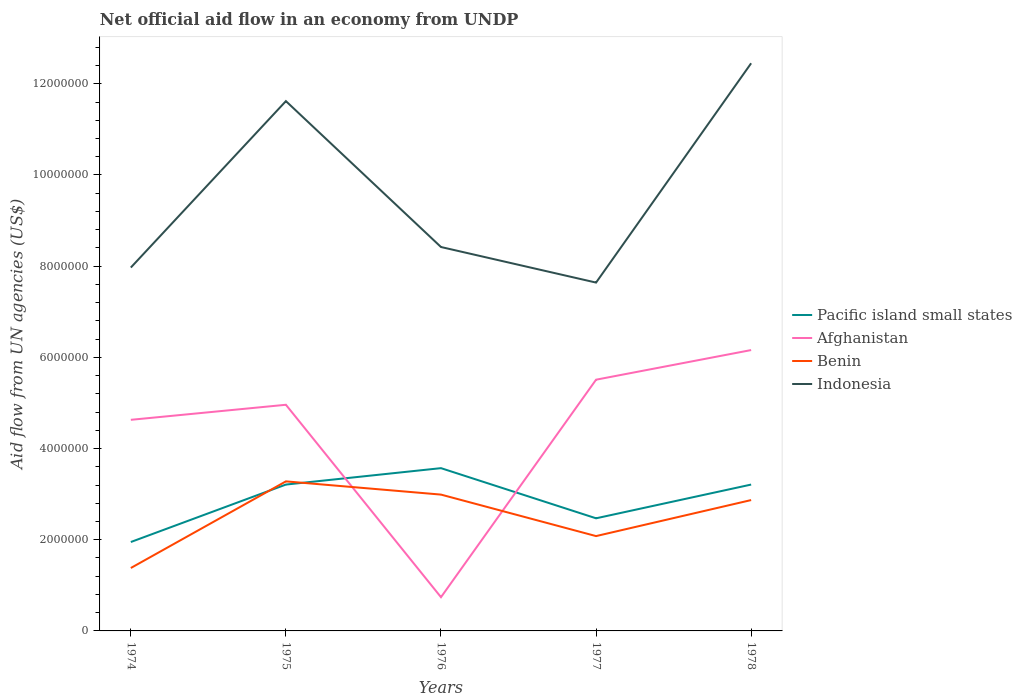How many different coloured lines are there?
Provide a succinct answer. 4. Is the number of lines equal to the number of legend labels?
Make the answer very short. Yes. Across all years, what is the maximum net official aid flow in Benin?
Make the answer very short. 1.38e+06. In which year was the net official aid flow in Benin maximum?
Offer a very short reply. 1974. What is the total net official aid flow in Indonesia in the graph?
Ensure brevity in your answer.  -4.48e+06. What is the difference between the highest and the second highest net official aid flow in Benin?
Offer a very short reply. 1.90e+06. What is the difference between the highest and the lowest net official aid flow in Indonesia?
Your answer should be very brief. 2. Are the values on the major ticks of Y-axis written in scientific E-notation?
Ensure brevity in your answer.  No. Does the graph contain any zero values?
Offer a very short reply. No. Does the graph contain grids?
Your response must be concise. No. What is the title of the graph?
Offer a very short reply. Net official aid flow in an economy from UNDP. Does "Lithuania" appear as one of the legend labels in the graph?
Provide a succinct answer. No. What is the label or title of the Y-axis?
Provide a succinct answer. Aid flow from UN agencies (US$). What is the Aid flow from UN agencies (US$) in Pacific island small states in 1974?
Ensure brevity in your answer.  1.95e+06. What is the Aid flow from UN agencies (US$) of Afghanistan in 1974?
Offer a very short reply. 4.63e+06. What is the Aid flow from UN agencies (US$) of Benin in 1974?
Your answer should be very brief. 1.38e+06. What is the Aid flow from UN agencies (US$) in Indonesia in 1974?
Provide a short and direct response. 7.97e+06. What is the Aid flow from UN agencies (US$) in Pacific island small states in 1975?
Provide a short and direct response. 3.21e+06. What is the Aid flow from UN agencies (US$) of Afghanistan in 1975?
Keep it short and to the point. 4.96e+06. What is the Aid flow from UN agencies (US$) of Benin in 1975?
Your response must be concise. 3.28e+06. What is the Aid flow from UN agencies (US$) of Indonesia in 1975?
Your answer should be compact. 1.16e+07. What is the Aid flow from UN agencies (US$) in Pacific island small states in 1976?
Provide a succinct answer. 3.57e+06. What is the Aid flow from UN agencies (US$) of Afghanistan in 1976?
Give a very brief answer. 7.40e+05. What is the Aid flow from UN agencies (US$) in Benin in 1976?
Your response must be concise. 2.99e+06. What is the Aid flow from UN agencies (US$) of Indonesia in 1976?
Your response must be concise. 8.42e+06. What is the Aid flow from UN agencies (US$) in Pacific island small states in 1977?
Provide a succinct answer. 2.47e+06. What is the Aid flow from UN agencies (US$) in Afghanistan in 1977?
Keep it short and to the point. 5.51e+06. What is the Aid flow from UN agencies (US$) in Benin in 1977?
Keep it short and to the point. 2.08e+06. What is the Aid flow from UN agencies (US$) in Indonesia in 1977?
Your answer should be compact. 7.64e+06. What is the Aid flow from UN agencies (US$) of Pacific island small states in 1978?
Provide a succinct answer. 3.21e+06. What is the Aid flow from UN agencies (US$) in Afghanistan in 1978?
Ensure brevity in your answer.  6.16e+06. What is the Aid flow from UN agencies (US$) of Benin in 1978?
Ensure brevity in your answer.  2.87e+06. What is the Aid flow from UN agencies (US$) in Indonesia in 1978?
Offer a terse response. 1.24e+07. Across all years, what is the maximum Aid flow from UN agencies (US$) of Pacific island small states?
Give a very brief answer. 3.57e+06. Across all years, what is the maximum Aid flow from UN agencies (US$) in Afghanistan?
Provide a short and direct response. 6.16e+06. Across all years, what is the maximum Aid flow from UN agencies (US$) in Benin?
Your response must be concise. 3.28e+06. Across all years, what is the maximum Aid flow from UN agencies (US$) in Indonesia?
Offer a terse response. 1.24e+07. Across all years, what is the minimum Aid flow from UN agencies (US$) in Pacific island small states?
Provide a short and direct response. 1.95e+06. Across all years, what is the minimum Aid flow from UN agencies (US$) of Afghanistan?
Your answer should be very brief. 7.40e+05. Across all years, what is the minimum Aid flow from UN agencies (US$) of Benin?
Offer a very short reply. 1.38e+06. Across all years, what is the minimum Aid flow from UN agencies (US$) in Indonesia?
Your answer should be very brief. 7.64e+06. What is the total Aid flow from UN agencies (US$) in Pacific island small states in the graph?
Give a very brief answer. 1.44e+07. What is the total Aid flow from UN agencies (US$) of Afghanistan in the graph?
Provide a succinct answer. 2.20e+07. What is the total Aid flow from UN agencies (US$) in Benin in the graph?
Your response must be concise. 1.26e+07. What is the total Aid flow from UN agencies (US$) in Indonesia in the graph?
Give a very brief answer. 4.81e+07. What is the difference between the Aid flow from UN agencies (US$) of Pacific island small states in 1974 and that in 1975?
Provide a short and direct response. -1.26e+06. What is the difference between the Aid flow from UN agencies (US$) of Afghanistan in 1974 and that in 1975?
Offer a very short reply. -3.30e+05. What is the difference between the Aid flow from UN agencies (US$) of Benin in 1974 and that in 1975?
Ensure brevity in your answer.  -1.90e+06. What is the difference between the Aid flow from UN agencies (US$) in Indonesia in 1974 and that in 1975?
Keep it short and to the point. -3.65e+06. What is the difference between the Aid flow from UN agencies (US$) of Pacific island small states in 1974 and that in 1976?
Make the answer very short. -1.62e+06. What is the difference between the Aid flow from UN agencies (US$) of Afghanistan in 1974 and that in 1976?
Ensure brevity in your answer.  3.89e+06. What is the difference between the Aid flow from UN agencies (US$) in Benin in 1974 and that in 1976?
Provide a succinct answer. -1.61e+06. What is the difference between the Aid flow from UN agencies (US$) in Indonesia in 1974 and that in 1976?
Your answer should be very brief. -4.50e+05. What is the difference between the Aid flow from UN agencies (US$) in Pacific island small states in 1974 and that in 1977?
Keep it short and to the point. -5.20e+05. What is the difference between the Aid flow from UN agencies (US$) of Afghanistan in 1974 and that in 1977?
Make the answer very short. -8.80e+05. What is the difference between the Aid flow from UN agencies (US$) of Benin in 1974 and that in 1977?
Provide a succinct answer. -7.00e+05. What is the difference between the Aid flow from UN agencies (US$) in Indonesia in 1974 and that in 1977?
Make the answer very short. 3.30e+05. What is the difference between the Aid flow from UN agencies (US$) of Pacific island small states in 1974 and that in 1978?
Your answer should be very brief. -1.26e+06. What is the difference between the Aid flow from UN agencies (US$) of Afghanistan in 1974 and that in 1978?
Provide a succinct answer. -1.53e+06. What is the difference between the Aid flow from UN agencies (US$) in Benin in 1974 and that in 1978?
Offer a terse response. -1.49e+06. What is the difference between the Aid flow from UN agencies (US$) in Indonesia in 1974 and that in 1978?
Your answer should be very brief. -4.48e+06. What is the difference between the Aid flow from UN agencies (US$) in Pacific island small states in 1975 and that in 1976?
Your response must be concise. -3.60e+05. What is the difference between the Aid flow from UN agencies (US$) in Afghanistan in 1975 and that in 1976?
Offer a terse response. 4.22e+06. What is the difference between the Aid flow from UN agencies (US$) in Benin in 1975 and that in 1976?
Ensure brevity in your answer.  2.90e+05. What is the difference between the Aid flow from UN agencies (US$) of Indonesia in 1975 and that in 1976?
Your answer should be compact. 3.20e+06. What is the difference between the Aid flow from UN agencies (US$) in Pacific island small states in 1975 and that in 1977?
Offer a terse response. 7.40e+05. What is the difference between the Aid flow from UN agencies (US$) in Afghanistan in 1975 and that in 1977?
Your response must be concise. -5.50e+05. What is the difference between the Aid flow from UN agencies (US$) of Benin in 1975 and that in 1977?
Your answer should be very brief. 1.20e+06. What is the difference between the Aid flow from UN agencies (US$) in Indonesia in 1975 and that in 1977?
Make the answer very short. 3.98e+06. What is the difference between the Aid flow from UN agencies (US$) of Pacific island small states in 1975 and that in 1978?
Give a very brief answer. 0. What is the difference between the Aid flow from UN agencies (US$) in Afghanistan in 1975 and that in 1978?
Ensure brevity in your answer.  -1.20e+06. What is the difference between the Aid flow from UN agencies (US$) in Benin in 1975 and that in 1978?
Keep it short and to the point. 4.10e+05. What is the difference between the Aid flow from UN agencies (US$) in Indonesia in 1975 and that in 1978?
Ensure brevity in your answer.  -8.30e+05. What is the difference between the Aid flow from UN agencies (US$) of Pacific island small states in 1976 and that in 1977?
Offer a terse response. 1.10e+06. What is the difference between the Aid flow from UN agencies (US$) of Afghanistan in 1976 and that in 1977?
Make the answer very short. -4.77e+06. What is the difference between the Aid flow from UN agencies (US$) of Benin in 1976 and that in 1977?
Ensure brevity in your answer.  9.10e+05. What is the difference between the Aid flow from UN agencies (US$) of Indonesia in 1976 and that in 1977?
Provide a succinct answer. 7.80e+05. What is the difference between the Aid flow from UN agencies (US$) in Afghanistan in 1976 and that in 1978?
Offer a very short reply. -5.42e+06. What is the difference between the Aid flow from UN agencies (US$) in Benin in 1976 and that in 1978?
Make the answer very short. 1.20e+05. What is the difference between the Aid flow from UN agencies (US$) of Indonesia in 1976 and that in 1978?
Your answer should be very brief. -4.03e+06. What is the difference between the Aid flow from UN agencies (US$) in Pacific island small states in 1977 and that in 1978?
Your answer should be very brief. -7.40e+05. What is the difference between the Aid flow from UN agencies (US$) of Afghanistan in 1977 and that in 1978?
Your answer should be very brief. -6.50e+05. What is the difference between the Aid flow from UN agencies (US$) in Benin in 1977 and that in 1978?
Give a very brief answer. -7.90e+05. What is the difference between the Aid flow from UN agencies (US$) of Indonesia in 1977 and that in 1978?
Provide a short and direct response. -4.81e+06. What is the difference between the Aid flow from UN agencies (US$) in Pacific island small states in 1974 and the Aid flow from UN agencies (US$) in Afghanistan in 1975?
Your answer should be compact. -3.01e+06. What is the difference between the Aid flow from UN agencies (US$) of Pacific island small states in 1974 and the Aid flow from UN agencies (US$) of Benin in 1975?
Give a very brief answer. -1.33e+06. What is the difference between the Aid flow from UN agencies (US$) of Pacific island small states in 1974 and the Aid flow from UN agencies (US$) of Indonesia in 1975?
Your response must be concise. -9.67e+06. What is the difference between the Aid flow from UN agencies (US$) of Afghanistan in 1974 and the Aid flow from UN agencies (US$) of Benin in 1975?
Provide a succinct answer. 1.35e+06. What is the difference between the Aid flow from UN agencies (US$) in Afghanistan in 1974 and the Aid flow from UN agencies (US$) in Indonesia in 1975?
Make the answer very short. -6.99e+06. What is the difference between the Aid flow from UN agencies (US$) in Benin in 1974 and the Aid flow from UN agencies (US$) in Indonesia in 1975?
Give a very brief answer. -1.02e+07. What is the difference between the Aid flow from UN agencies (US$) in Pacific island small states in 1974 and the Aid flow from UN agencies (US$) in Afghanistan in 1976?
Your answer should be compact. 1.21e+06. What is the difference between the Aid flow from UN agencies (US$) in Pacific island small states in 1974 and the Aid flow from UN agencies (US$) in Benin in 1976?
Offer a terse response. -1.04e+06. What is the difference between the Aid flow from UN agencies (US$) in Pacific island small states in 1974 and the Aid flow from UN agencies (US$) in Indonesia in 1976?
Keep it short and to the point. -6.47e+06. What is the difference between the Aid flow from UN agencies (US$) in Afghanistan in 1974 and the Aid flow from UN agencies (US$) in Benin in 1976?
Ensure brevity in your answer.  1.64e+06. What is the difference between the Aid flow from UN agencies (US$) of Afghanistan in 1974 and the Aid flow from UN agencies (US$) of Indonesia in 1976?
Offer a terse response. -3.79e+06. What is the difference between the Aid flow from UN agencies (US$) in Benin in 1974 and the Aid flow from UN agencies (US$) in Indonesia in 1976?
Your answer should be compact. -7.04e+06. What is the difference between the Aid flow from UN agencies (US$) in Pacific island small states in 1974 and the Aid flow from UN agencies (US$) in Afghanistan in 1977?
Give a very brief answer. -3.56e+06. What is the difference between the Aid flow from UN agencies (US$) in Pacific island small states in 1974 and the Aid flow from UN agencies (US$) in Indonesia in 1977?
Your response must be concise. -5.69e+06. What is the difference between the Aid flow from UN agencies (US$) in Afghanistan in 1974 and the Aid flow from UN agencies (US$) in Benin in 1977?
Offer a terse response. 2.55e+06. What is the difference between the Aid flow from UN agencies (US$) in Afghanistan in 1974 and the Aid flow from UN agencies (US$) in Indonesia in 1977?
Give a very brief answer. -3.01e+06. What is the difference between the Aid flow from UN agencies (US$) in Benin in 1974 and the Aid flow from UN agencies (US$) in Indonesia in 1977?
Make the answer very short. -6.26e+06. What is the difference between the Aid flow from UN agencies (US$) in Pacific island small states in 1974 and the Aid flow from UN agencies (US$) in Afghanistan in 1978?
Give a very brief answer. -4.21e+06. What is the difference between the Aid flow from UN agencies (US$) in Pacific island small states in 1974 and the Aid flow from UN agencies (US$) in Benin in 1978?
Offer a very short reply. -9.20e+05. What is the difference between the Aid flow from UN agencies (US$) in Pacific island small states in 1974 and the Aid flow from UN agencies (US$) in Indonesia in 1978?
Your answer should be compact. -1.05e+07. What is the difference between the Aid flow from UN agencies (US$) in Afghanistan in 1974 and the Aid flow from UN agencies (US$) in Benin in 1978?
Ensure brevity in your answer.  1.76e+06. What is the difference between the Aid flow from UN agencies (US$) in Afghanistan in 1974 and the Aid flow from UN agencies (US$) in Indonesia in 1978?
Provide a short and direct response. -7.82e+06. What is the difference between the Aid flow from UN agencies (US$) of Benin in 1974 and the Aid flow from UN agencies (US$) of Indonesia in 1978?
Your answer should be very brief. -1.11e+07. What is the difference between the Aid flow from UN agencies (US$) of Pacific island small states in 1975 and the Aid flow from UN agencies (US$) of Afghanistan in 1976?
Provide a succinct answer. 2.47e+06. What is the difference between the Aid flow from UN agencies (US$) in Pacific island small states in 1975 and the Aid flow from UN agencies (US$) in Indonesia in 1976?
Provide a short and direct response. -5.21e+06. What is the difference between the Aid flow from UN agencies (US$) in Afghanistan in 1975 and the Aid flow from UN agencies (US$) in Benin in 1976?
Provide a succinct answer. 1.97e+06. What is the difference between the Aid flow from UN agencies (US$) in Afghanistan in 1975 and the Aid flow from UN agencies (US$) in Indonesia in 1976?
Make the answer very short. -3.46e+06. What is the difference between the Aid flow from UN agencies (US$) in Benin in 1975 and the Aid flow from UN agencies (US$) in Indonesia in 1976?
Your answer should be very brief. -5.14e+06. What is the difference between the Aid flow from UN agencies (US$) of Pacific island small states in 1975 and the Aid flow from UN agencies (US$) of Afghanistan in 1977?
Provide a short and direct response. -2.30e+06. What is the difference between the Aid flow from UN agencies (US$) of Pacific island small states in 1975 and the Aid flow from UN agencies (US$) of Benin in 1977?
Offer a terse response. 1.13e+06. What is the difference between the Aid flow from UN agencies (US$) of Pacific island small states in 1975 and the Aid flow from UN agencies (US$) of Indonesia in 1977?
Offer a terse response. -4.43e+06. What is the difference between the Aid flow from UN agencies (US$) of Afghanistan in 1975 and the Aid flow from UN agencies (US$) of Benin in 1977?
Your answer should be very brief. 2.88e+06. What is the difference between the Aid flow from UN agencies (US$) in Afghanistan in 1975 and the Aid flow from UN agencies (US$) in Indonesia in 1977?
Offer a very short reply. -2.68e+06. What is the difference between the Aid flow from UN agencies (US$) in Benin in 1975 and the Aid flow from UN agencies (US$) in Indonesia in 1977?
Provide a succinct answer. -4.36e+06. What is the difference between the Aid flow from UN agencies (US$) in Pacific island small states in 1975 and the Aid flow from UN agencies (US$) in Afghanistan in 1978?
Keep it short and to the point. -2.95e+06. What is the difference between the Aid flow from UN agencies (US$) of Pacific island small states in 1975 and the Aid flow from UN agencies (US$) of Benin in 1978?
Ensure brevity in your answer.  3.40e+05. What is the difference between the Aid flow from UN agencies (US$) in Pacific island small states in 1975 and the Aid flow from UN agencies (US$) in Indonesia in 1978?
Provide a short and direct response. -9.24e+06. What is the difference between the Aid flow from UN agencies (US$) in Afghanistan in 1975 and the Aid flow from UN agencies (US$) in Benin in 1978?
Provide a short and direct response. 2.09e+06. What is the difference between the Aid flow from UN agencies (US$) in Afghanistan in 1975 and the Aid flow from UN agencies (US$) in Indonesia in 1978?
Your response must be concise. -7.49e+06. What is the difference between the Aid flow from UN agencies (US$) in Benin in 1975 and the Aid flow from UN agencies (US$) in Indonesia in 1978?
Your response must be concise. -9.17e+06. What is the difference between the Aid flow from UN agencies (US$) of Pacific island small states in 1976 and the Aid flow from UN agencies (US$) of Afghanistan in 1977?
Offer a very short reply. -1.94e+06. What is the difference between the Aid flow from UN agencies (US$) of Pacific island small states in 1976 and the Aid flow from UN agencies (US$) of Benin in 1977?
Your answer should be compact. 1.49e+06. What is the difference between the Aid flow from UN agencies (US$) of Pacific island small states in 1976 and the Aid flow from UN agencies (US$) of Indonesia in 1977?
Your response must be concise. -4.07e+06. What is the difference between the Aid flow from UN agencies (US$) in Afghanistan in 1976 and the Aid flow from UN agencies (US$) in Benin in 1977?
Your answer should be very brief. -1.34e+06. What is the difference between the Aid flow from UN agencies (US$) of Afghanistan in 1976 and the Aid flow from UN agencies (US$) of Indonesia in 1977?
Keep it short and to the point. -6.90e+06. What is the difference between the Aid flow from UN agencies (US$) in Benin in 1976 and the Aid flow from UN agencies (US$) in Indonesia in 1977?
Provide a short and direct response. -4.65e+06. What is the difference between the Aid flow from UN agencies (US$) of Pacific island small states in 1976 and the Aid flow from UN agencies (US$) of Afghanistan in 1978?
Your answer should be very brief. -2.59e+06. What is the difference between the Aid flow from UN agencies (US$) in Pacific island small states in 1976 and the Aid flow from UN agencies (US$) in Benin in 1978?
Provide a short and direct response. 7.00e+05. What is the difference between the Aid flow from UN agencies (US$) in Pacific island small states in 1976 and the Aid flow from UN agencies (US$) in Indonesia in 1978?
Keep it short and to the point. -8.88e+06. What is the difference between the Aid flow from UN agencies (US$) of Afghanistan in 1976 and the Aid flow from UN agencies (US$) of Benin in 1978?
Offer a very short reply. -2.13e+06. What is the difference between the Aid flow from UN agencies (US$) of Afghanistan in 1976 and the Aid flow from UN agencies (US$) of Indonesia in 1978?
Provide a succinct answer. -1.17e+07. What is the difference between the Aid flow from UN agencies (US$) in Benin in 1976 and the Aid flow from UN agencies (US$) in Indonesia in 1978?
Your answer should be very brief. -9.46e+06. What is the difference between the Aid flow from UN agencies (US$) in Pacific island small states in 1977 and the Aid flow from UN agencies (US$) in Afghanistan in 1978?
Provide a short and direct response. -3.69e+06. What is the difference between the Aid flow from UN agencies (US$) in Pacific island small states in 1977 and the Aid flow from UN agencies (US$) in Benin in 1978?
Give a very brief answer. -4.00e+05. What is the difference between the Aid flow from UN agencies (US$) of Pacific island small states in 1977 and the Aid flow from UN agencies (US$) of Indonesia in 1978?
Your response must be concise. -9.98e+06. What is the difference between the Aid flow from UN agencies (US$) in Afghanistan in 1977 and the Aid flow from UN agencies (US$) in Benin in 1978?
Keep it short and to the point. 2.64e+06. What is the difference between the Aid flow from UN agencies (US$) in Afghanistan in 1977 and the Aid flow from UN agencies (US$) in Indonesia in 1978?
Provide a short and direct response. -6.94e+06. What is the difference between the Aid flow from UN agencies (US$) of Benin in 1977 and the Aid flow from UN agencies (US$) of Indonesia in 1978?
Keep it short and to the point. -1.04e+07. What is the average Aid flow from UN agencies (US$) in Pacific island small states per year?
Keep it short and to the point. 2.88e+06. What is the average Aid flow from UN agencies (US$) of Afghanistan per year?
Give a very brief answer. 4.40e+06. What is the average Aid flow from UN agencies (US$) of Benin per year?
Provide a short and direct response. 2.52e+06. What is the average Aid flow from UN agencies (US$) of Indonesia per year?
Your answer should be compact. 9.62e+06. In the year 1974, what is the difference between the Aid flow from UN agencies (US$) of Pacific island small states and Aid flow from UN agencies (US$) of Afghanistan?
Your answer should be compact. -2.68e+06. In the year 1974, what is the difference between the Aid flow from UN agencies (US$) in Pacific island small states and Aid flow from UN agencies (US$) in Benin?
Provide a succinct answer. 5.70e+05. In the year 1974, what is the difference between the Aid flow from UN agencies (US$) of Pacific island small states and Aid flow from UN agencies (US$) of Indonesia?
Keep it short and to the point. -6.02e+06. In the year 1974, what is the difference between the Aid flow from UN agencies (US$) of Afghanistan and Aid flow from UN agencies (US$) of Benin?
Offer a terse response. 3.25e+06. In the year 1974, what is the difference between the Aid flow from UN agencies (US$) in Afghanistan and Aid flow from UN agencies (US$) in Indonesia?
Your answer should be very brief. -3.34e+06. In the year 1974, what is the difference between the Aid flow from UN agencies (US$) in Benin and Aid flow from UN agencies (US$) in Indonesia?
Your response must be concise. -6.59e+06. In the year 1975, what is the difference between the Aid flow from UN agencies (US$) of Pacific island small states and Aid flow from UN agencies (US$) of Afghanistan?
Make the answer very short. -1.75e+06. In the year 1975, what is the difference between the Aid flow from UN agencies (US$) in Pacific island small states and Aid flow from UN agencies (US$) in Benin?
Provide a short and direct response. -7.00e+04. In the year 1975, what is the difference between the Aid flow from UN agencies (US$) of Pacific island small states and Aid flow from UN agencies (US$) of Indonesia?
Provide a succinct answer. -8.41e+06. In the year 1975, what is the difference between the Aid flow from UN agencies (US$) in Afghanistan and Aid flow from UN agencies (US$) in Benin?
Your answer should be very brief. 1.68e+06. In the year 1975, what is the difference between the Aid flow from UN agencies (US$) in Afghanistan and Aid flow from UN agencies (US$) in Indonesia?
Ensure brevity in your answer.  -6.66e+06. In the year 1975, what is the difference between the Aid flow from UN agencies (US$) of Benin and Aid flow from UN agencies (US$) of Indonesia?
Offer a terse response. -8.34e+06. In the year 1976, what is the difference between the Aid flow from UN agencies (US$) of Pacific island small states and Aid flow from UN agencies (US$) of Afghanistan?
Offer a very short reply. 2.83e+06. In the year 1976, what is the difference between the Aid flow from UN agencies (US$) in Pacific island small states and Aid flow from UN agencies (US$) in Benin?
Provide a succinct answer. 5.80e+05. In the year 1976, what is the difference between the Aid flow from UN agencies (US$) of Pacific island small states and Aid flow from UN agencies (US$) of Indonesia?
Your response must be concise. -4.85e+06. In the year 1976, what is the difference between the Aid flow from UN agencies (US$) in Afghanistan and Aid flow from UN agencies (US$) in Benin?
Your answer should be very brief. -2.25e+06. In the year 1976, what is the difference between the Aid flow from UN agencies (US$) in Afghanistan and Aid flow from UN agencies (US$) in Indonesia?
Offer a terse response. -7.68e+06. In the year 1976, what is the difference between the Aid flow from UN agencies (US$) in Benin and Aid flow from UN agencies (US$) in Indonesia?
Your answer should be very brief. -5.43e+06. In the year 1977, what is the difference between the Aid flow from UN agencies (US$) in Pacific island small states and Aid flow from UN agencies (US$) in Afghanistan?
Your answer should be compact. -3.04e+06. In the year 1977, what is the difference between the Aid flow from UN agencies (US$) in Pacific island small states and Aid flow from UN agencies (US$) in Benin?
Ensure brevity in your answer.  3.90e+05. In the year 1977, what is the difference between the Aid flow from UN agencies (US$) in Pacific island small states and Aid flow from UN agencies (US$) in Indonesia?
Provide a short and direct response. -5.17e+06. In the year 1977, what is the difference between the Aid flow from UN agencies (US$) in Afghanistan and Aid flow from UN agencies (US$) in Benin?
Offer a terse response. 3.43e+06. In the year 1977, what is the difference between the Aid flow from UN agencies (US$) of Afghanistan and Aid flow from UN agencies (US$) of Indonesia?
Provide a succinct answer. -2.13e+06. In the year 1977, what is the difference between the Aid flow from UN agencies (US$) of Benin and Aid flow from UN agencies (US$) of Indonesia?
Give a very brief answer. -5.56e+06. In the year 1978, what is the difference between the Aid flow from UN agencies (US$) in Pacific island small states and Aid flow from UN agencies (US$) in Afghanistan?
Keep it short and to the point. -2.95e+06. In the year 1978, what is the difference between the Aid flow from UN agencies (US$) of Pacific island small states and Aid flow from UN agencies (US$) of Indonesia?
Keep it short and to the point. -9.24e+06. In the year 1978, what is the difference between the Aid flow from UN agencies (US$) of Afghanistan and Aid flow from UN agencies (US$) of Benin?
Offer a terse response. 3.29e+06. In the year 1978, what is the difference between the Aid flow from UN agencies (US$) of Afghanistan and Aid flow from UN agencies (US$) of Indonesia?
Your response must be concise. -6.29e+06. In the year 1978, what is the difference between the Aid flow from UN agencies (US$) of Benin and Aid flow from UN agencies (US$) of Indonesia?
Offer a terse response. -9.58e+06. What is the ratio of the Aid flow from UN agencies (US$) of Pacific island small states in 1974 to that in 1975?
Give a very brief answer. 0.61. What is the ratio of the Aid flow from UN agencies (US$) in Afghanistan in 1974 to that in 1975?
Offer a very short reply. 0.93. What is the ratio of the Aid flow from UN agencies (US$) in Benin in 1974 to that in 1975?
Your response must be concise. 0.42. What is the ratio of the Aid flow from UN agencies (US$) of Indonesia in 1974 to that in 1975?
Ensure brevity in your answer.  0.69. What is the ratio of the Aid flow from UN agencies (US$) in Pacific island small states in 1974 to that in 1976?
Ensure brevity in your answer.  0.55. What is the ratio of the Aid flow from UN agencies (US$) in Afghanistan in 1974 to that in 1976?
Offer a very short reply. 6.26. What is the ratio of the Aid flow from UN agencies (US$) of Benin in 1974 to that in 1976?
Your answer should be very brief. 0.46. What is the ratio of the Aid flow from UN agencies (US$) of Indonesia in 1974 to that in 1976?
Keep it short and to the point. 0.95. What is the ratio of the Aid flow from UN agencies (US$) in Pacific island small states in 1974 to that in 1977?
Provide a succinct answer. 0.79. What is the ratio of the Aid flow from UN agencies (US$) in Afghanistan in 1974 to that in 1977?
Offer a very short reply. 0.84. What is the ratio of the Aid flow from UN agencies (US$) in Benin in 1974 to that in 1977?
Provide a succinct answer. 0.66. What is the ratio of the Aid flow from UN agencies (US$) of Indonesia in 1974 to that in 1977?
Your answer should be very brief. 1.04. What is the ratio of the Aid flow from UN agencies (US$) of Pacific island small states in 1974 to that in 1978?
Give a very brief answer. 0.61. What is the ratio of the Aid flow from UN agencies (US$) of Afghanistan in 1974 to that in 1978?
Your answer should be compact. 0.75. What is the ratio of the Aid flow from UN agencies (US$) of Benin in 1974 to that in 1978?
Give a very brief answer. 0.48. What is the ratio of the Aid flow from UN agencies (US$) in Indonesia in 1974 to that in 1978?
Provide a succinct answer. 0.64. What is the ratio of the Aid flow from UN agencies (US$) of Pacific island small states in 1975 to that in 1976?
Offer a terse response. 0.9. What is the ratio of the Aid flow from UN agencies (US$) in Afghanistan in 1975 to that in 1976?
Ensure brevity in your answer.  6.7. What is the ratio of the Aid flow from UN agencies (US$) of Benin in 1975 to that in 1976?
Offer a very short reply. 1.1. What is the ratio of the Aid flow from UN agencies (US$) in Indonesia in 1975 to that in 1976?
Keep it short and to the point. 1.38. What is the ratio of the Aid flow from UN agencies (US$) in Pacific island small states in 1975 to that in 1977?
Your response must be concise. 1.3. What is the ratio of the Aid flow from UN agencies (US$) of Afghanistan in 1975 to that in 1977?
Provide a succinct answer. 0.9. What is the ratio of the Aid flow from UN agencies (US$) in Benin in 1975 to that in 1977?
Give a very brief answer. 1.58. What is the ratio of the Aid flow from UN agencies (US$) of Indonesia in 1975 to that in 1977?
Ensure brevity in your answer.  1.52. What is the ratio of the Aid flow from UN agencies (US$) of Pacific island small states in 1975 to that in 1978?
Your response must be concise. 1. What is the ratio of the Aid flow from UN agencies (US$) of Afghanistan in 1975 to that in 1978?
Keep it short and to the point. 0.81. What is the ratio of the Aid flow from UN agencies (US$) in Benin in 1975 to that in 1978?
Your answer should be very brief. 1.14. What is the ratio of the Aid flow from UN agencies (US$) of Pacific island small states in 1976 to that in 1977?
Give a very brief answer. 1.45. What is the ratio of the Aid flow from UN agencies (US$) in Afghanistan in 1976 to that in 1977?
Give a very brief answer. 0.13. What is the ratio of the Aid flow from UN agencies (US$) in Benin in 1976 to that in 1977?
Provide a short and direct response. 1.44. What is the ratio of the Aid flow from UN agencies (US$) in Indonesia in 1976 to that in 1977?
Offer a very short reply. 1.1. What is the ratio of the Aid flow from UN agencies (US$) of Pacific island small states in 1976 to that in 1978?
Offer a terse response. 1.11. What is the ratio of the Aid flow from UN agencies (US$) of Afghanistan in 1976 to that in 1978?
Your answer should be very brief. 0.12. What is the ratio of the Aid flow from UN agencies (US$) in Benin in 1976 to that in 1978?
Offer a terse response. 1.04. What is the ratio of the Aid flow from UN agencies (US$) of Indonesia in 1976 to that in 1978?
Provide a succinct answer. 0.68. What is the ratio of the Aid flow from UN agencies (US$) of Pacific island small states in 1977 to that in 1978?
Make the answer very short. 0.77. What is the ratio of the Aid flow from UN agencies (US$) of Afghanistan in 1977 to that in 1978?
Provide a short and direct response. 0.89. What is the ratio of the Aid flow from UN agencies (US$) in Benin in 1977 to that in 1978?
Keep it short and to the point. 0.72. What is the ratio of the Aid flow from UN agencies (US$) in Indonesia in 1977 to that in 1978?
Provide a short and direct response. 0.61. What is the difference between the highest and the second highest Aid flow from UN agencies (US$) in Afghanistan?
Provide a short and direct response. 6.50e+05. What is the difference between the highest and the second highest Aid flow from UN agencies (US$) of Benin?
Provide a short and direct response. 2.90e+05. What is the difference between the highest and the second highest Aid flow from UN agencies (US$) of Indonesia?
Your response must be concise. 8.30e+05. What is the difference between the highest and the lowest Aid flow from UN agencies (US$) in Pacific island small states?
Offer a terse response. 1.62e+06. What is the difference between the highest and the lowest Aid flow from UN agencies (US$) in Afghanistan?
Provide a succinct answer. 5.42e+06. What is the difference between the highest and the lowest Aid flow from UN agencies (US$) in Benin?
Provide a short and direct response. 1.90e+06. What is the difference between the highest and the lowest Aid flow from UN agencies (US$) in Indonesia?
Your response must be concise. 4.81e+06. 